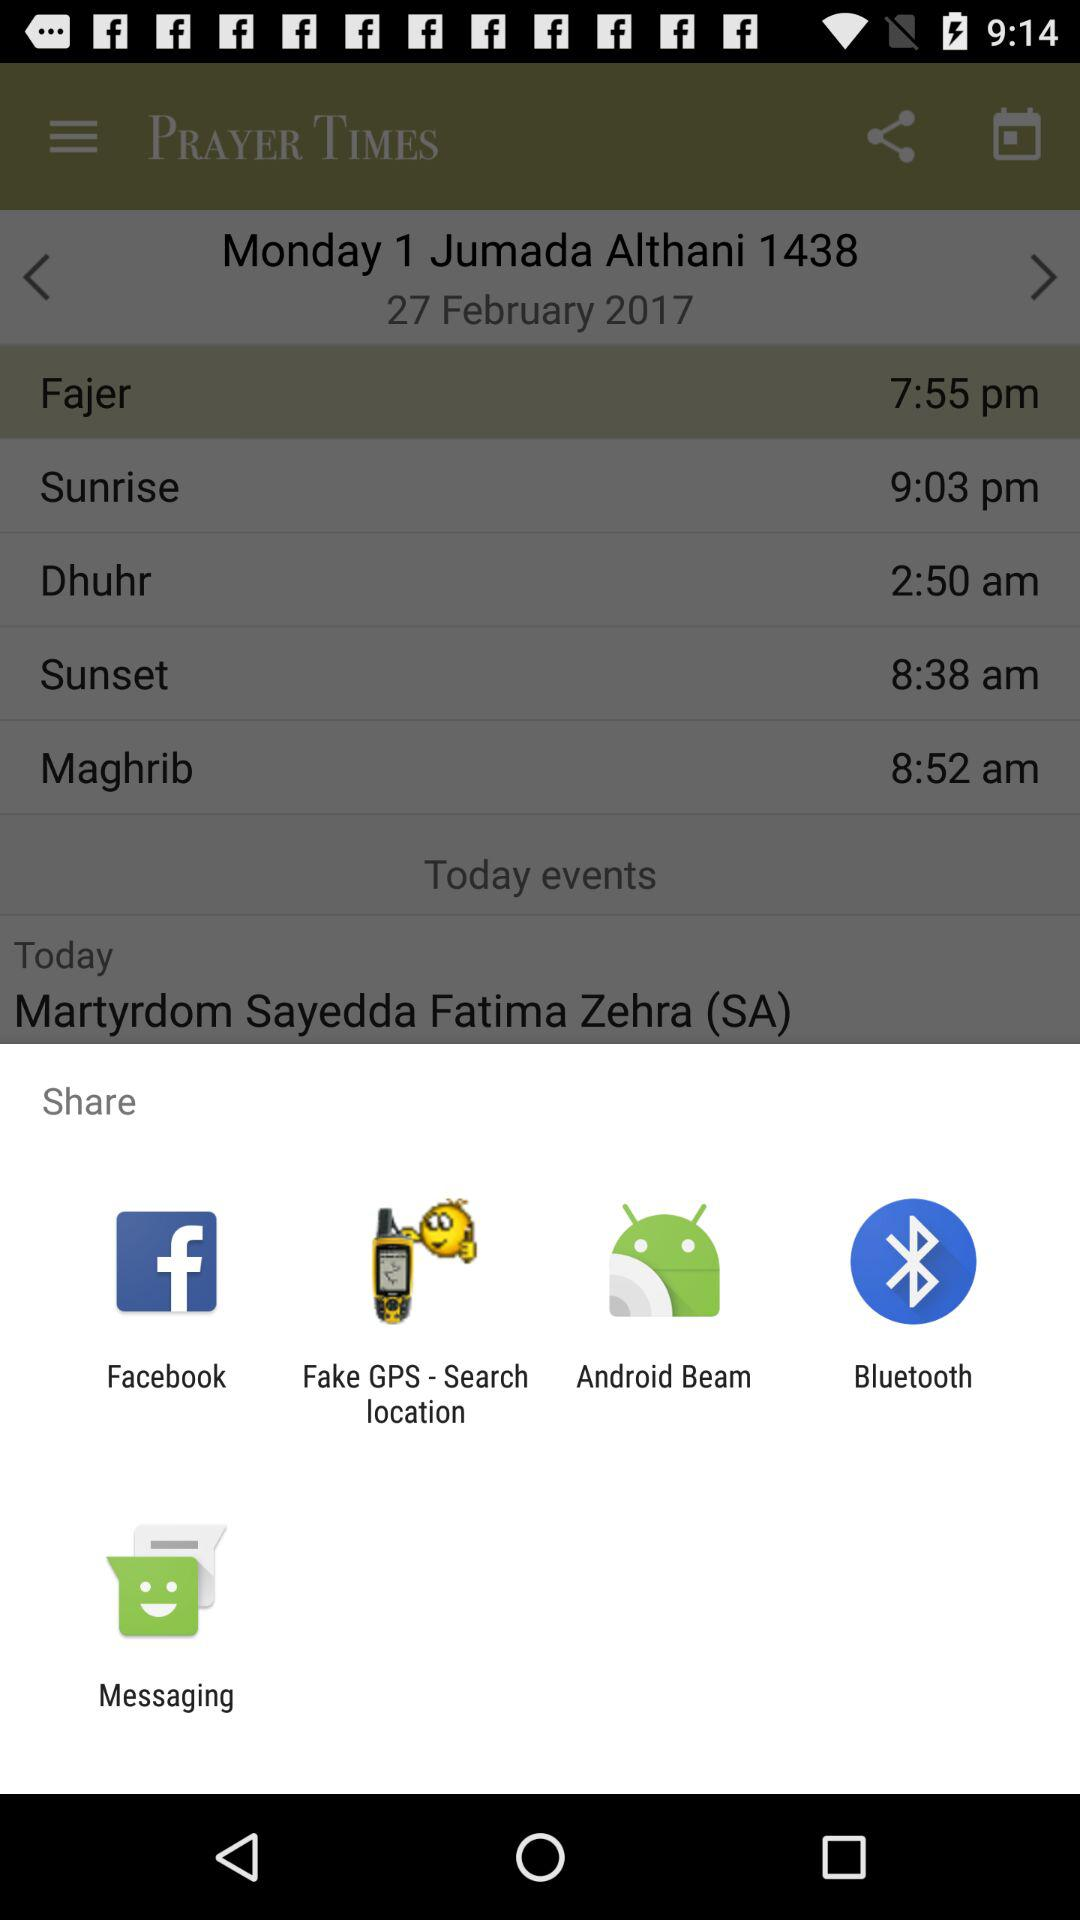Through which applications can the content be shared? The content can be shared through "Facebook", "Fake GPS - Search location", "Android Beam", "Bluetooth" and "Messaging". 